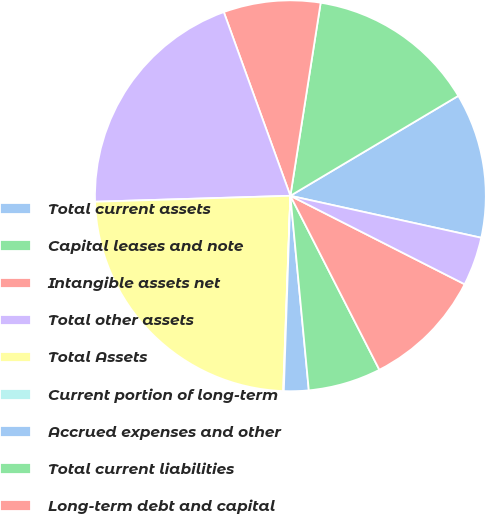Convert chart. <chart><loc_0><loc_0><loc_500><loc_500><pie_chart><fcel>Total current assets<fcel>Capital leases and note<fcel>Intangible assets net<fcel>Total other assets<fcel>Total Assets<fcel>Current portion of long-term<fcel>Accrued expenses and other<fcel>Total current liabilities<fcel>Long-term debt and capital<fcel>Derivative instruments<nl><fcel>11.99%<fcel>13.98%<fcel>8.01%<fcel>19.95%<fcel>23.93%<fcel>0.05%<fcel>2.04%<fcel>6.02%<fcel>10.0%<fcel>4.03%<nl></chart> 